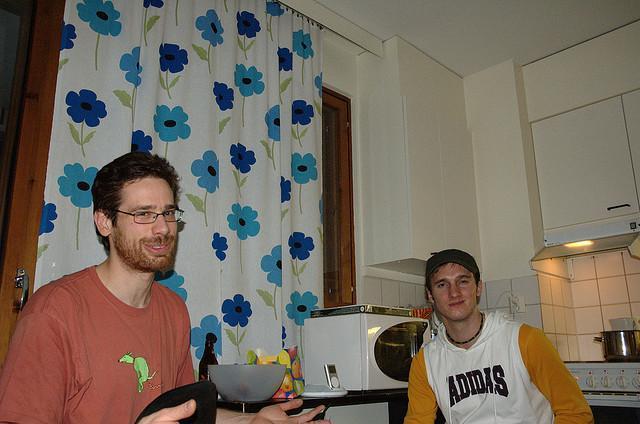How many men wearing eyeglasses?
Give a very brief answer. 1. How many people can you see?
Give a very brief answer. 2. How many clocks are there?
Give a very brief answer. 0. 